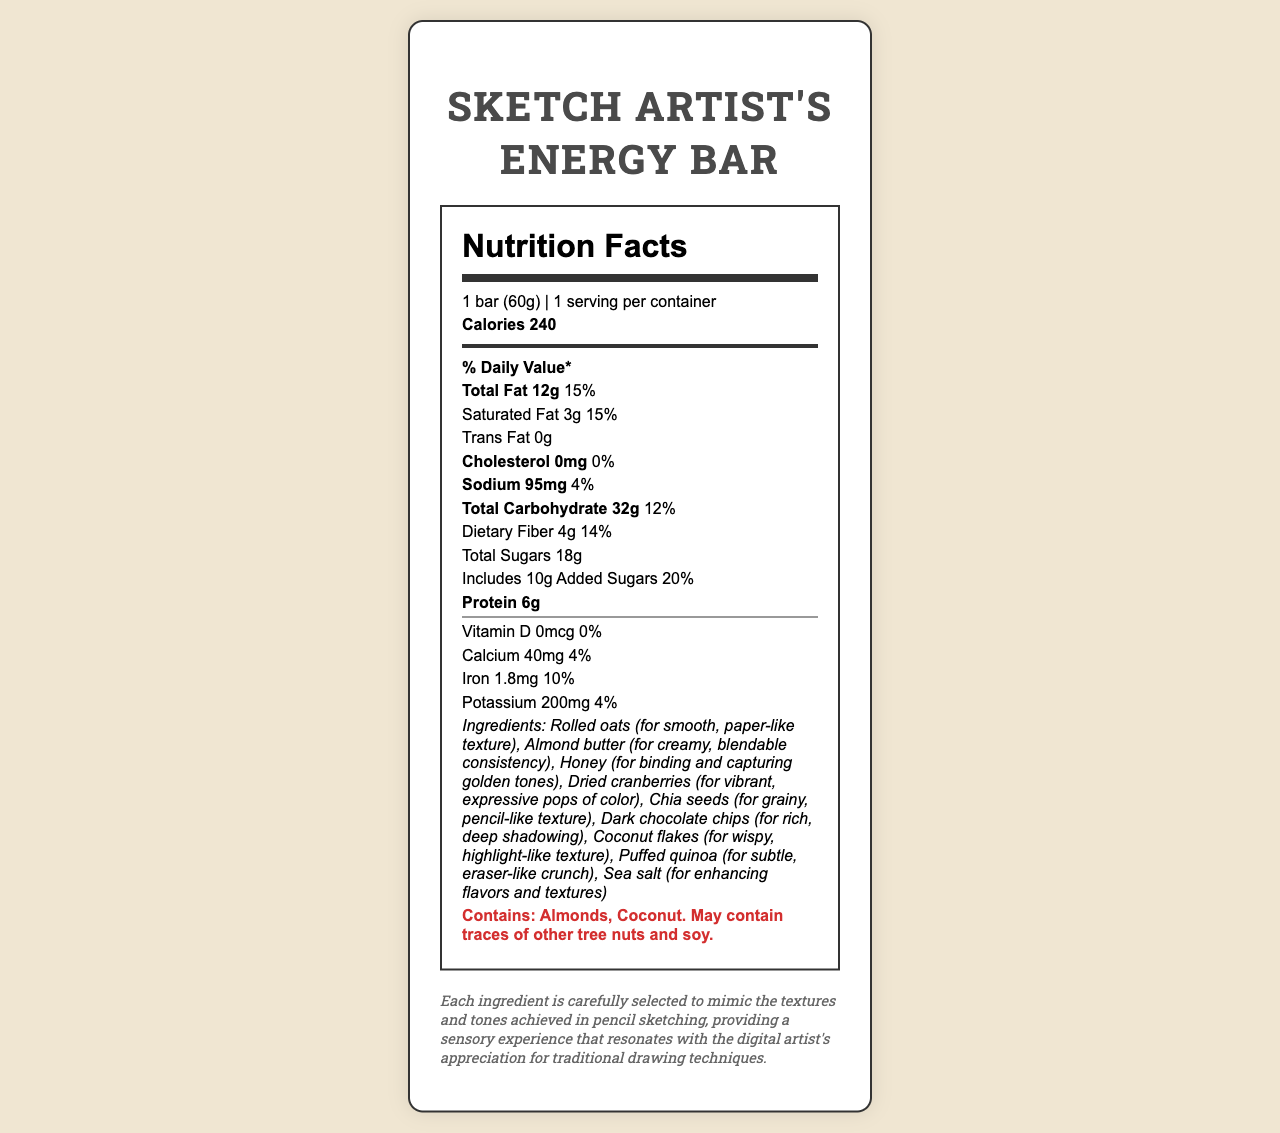what is the serving size? The document specifies the serving size as "1 bar (60g)" under the Nutrition Facts header.
Answer: 1 bar (60g) how many calories are in one serving? The document lists "Calories 240" clearly under the serving size information.
Answer: 240 what is the total fat content per serving? The total fat content is specified as "Total Fat 12g" in the Nutrition Facts section.
Answer: 12g how much dietary fiber does one bar contain? The document mentions "Dietary Fiber 4g" in the list of nutritional information.
Answer: 4g how many added sugars are in the bar? The label indicates "Includes 10g Added Sugars" under the sugars section.
Answer: 10g how much sodium is in one bar? The sodium content per bar is listed as "Sodium 95mg" in the nutrition information.
Answer: 95mg how much calcium does one serving provide? The calcium content is given as "Calcium 40mg" in the vitamin and mineral information section.
Answer: 40mg does the bar contain any cholesterol? The cholesterol content is listed as "Cholesterol 0mg (0% DV)," indicating there is no cholesterol in the bar.
Answer: No which ingredient provides a creamy, blendable consistency? According to the ingredients list, almond butter is included for its creamy, blendable consistency.
Answer: Almond butter which ingredient is added for rich, deep shadowing? The document mentions that dark chocolate chips are used for rich, deep shadowing.
Answer: Dark chocolate chips what are the total carbohydrates per serving? The nutrition label specifies that the total carbohydrate content is "Total Carbohydrate 32g."
Answer: 32g are there any tree nuts in the energy bar? The allergen information states that the bar "Contains: Almonds, Coconut" and may contain traces of other tree nuts.
Answer: Yes which ingredient is used for a smooth, paper-like texture? The ingredients list notes that rolled oats are included for their smooth, paper-like texture.
Answer: Rolled oats what percentage of daily value is provided by the saturated fat? The document lists saturated fat as "Saturated Fat 3g (15% DV)."
Answer: 15% what is the main idea of the document? The document provides the nutrition facts for the "Sketch Artist's Energy Bar," along with an overview of its ingredients, allergen information, and artist inspiration related to pencil sketching textures.
Answer: A handcrafted energy bar with nutrient breakdown and ingredient inspiration which ingredient contributes to vibrant, expressive pops of color? The ingredient list identifies dried cranberries as contributing vibrant, expressive pops of color.
Answer: Dried cranberries is the iron content more than 2mg? A. Yes B. No The document lists the iron content as "Iron 1.8mg," which is less than 2mg.
Answer: B. No which of the following vitamins or minerals is present in the highest amount? A. Vitamin D B. Calcium C. Iron D. Potassium The potassium content is 200mg, which is higher than that of vitamin D (0mcg), calcium (40mg), and iron (1.8mg).
Answer: D. Potassium does the bar contain any trans fat? The document clearly states "Trans Fat 0g," indicating there is no trans fat in the energy bar.
Answer: No how does the artist inspiration explain the choice of ingredients? The artist inspiration provided explains that the ingredients were chosen to mimic the textures and tones achieved in pencil sketching, enhancing the sensory experience.
Answer: Each ingredient is carefully selected to mimic pencil sketching textures what is the daily value percentage for protein? The document does not provide the daily value percentage for protein, only the amount (6g).
Answer: Not specified 